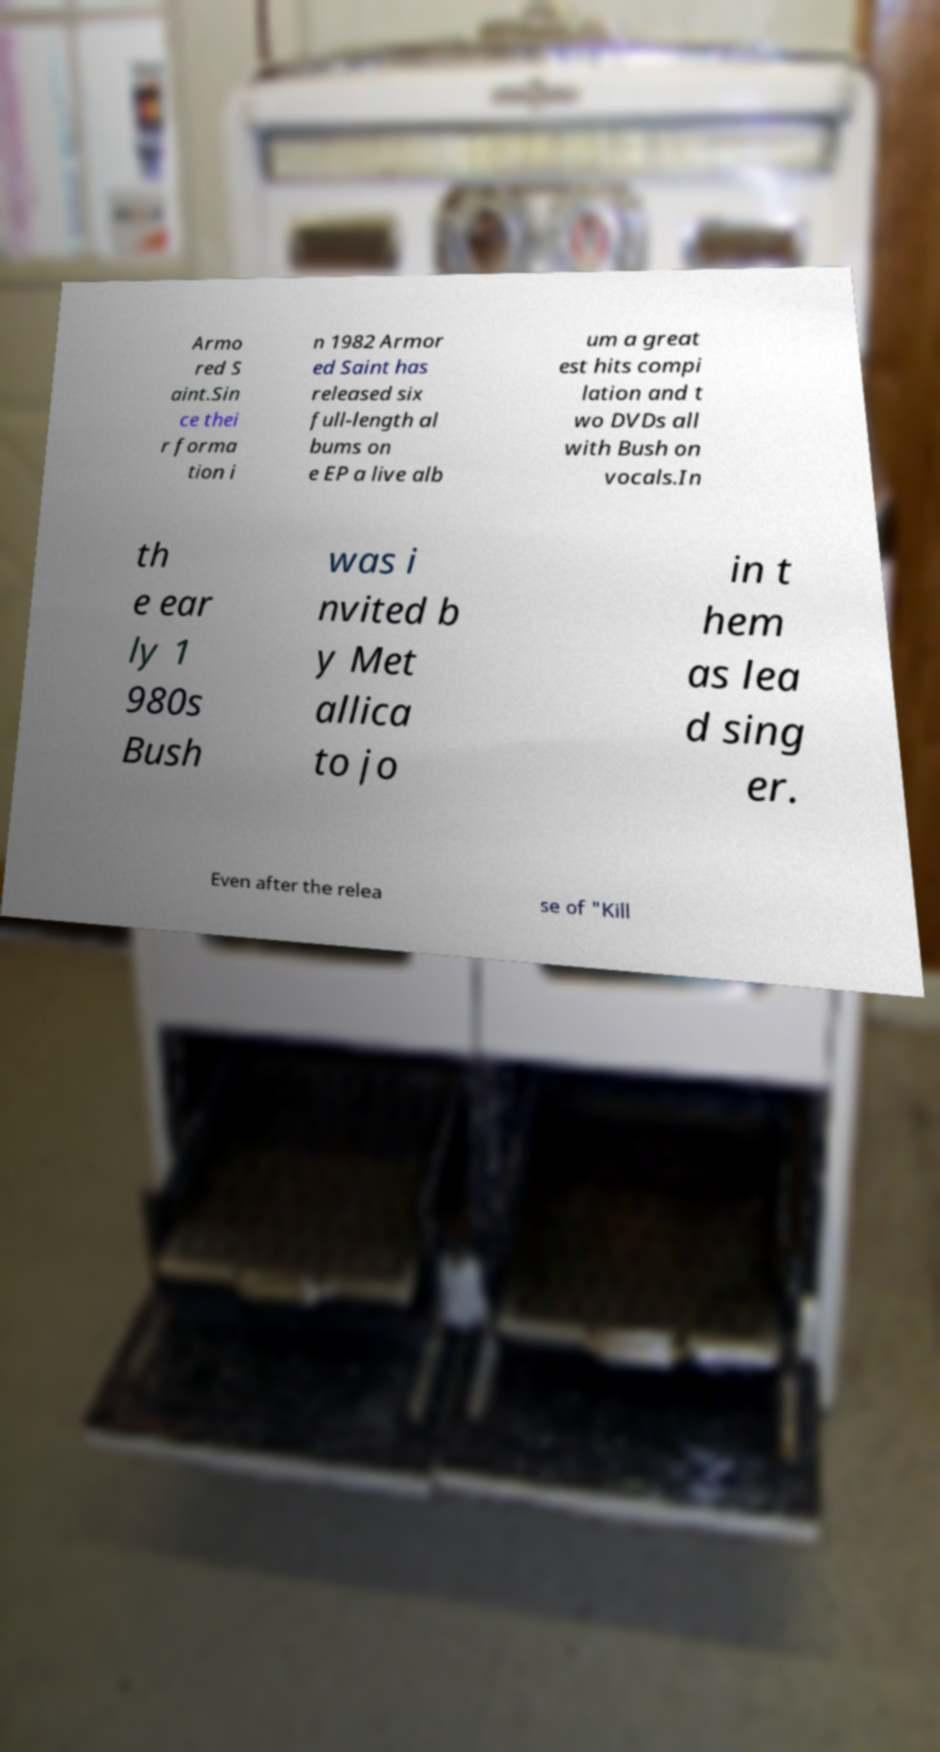For documentation purposes, I need the text within this image transcribed. Could you provide that? Armo red S aint.Sin ce thei r forma tion i n 1982 Armor ed Saint has released six full-length al bums on e EP a live alb um a great est hits compi lation and t wo DVDs all with Bush on vocals.In th e ear ly 1 980s Bush was i nvited b y Met allica to jo in t hem as lea d sing er. Even after the relea se of "Kill 